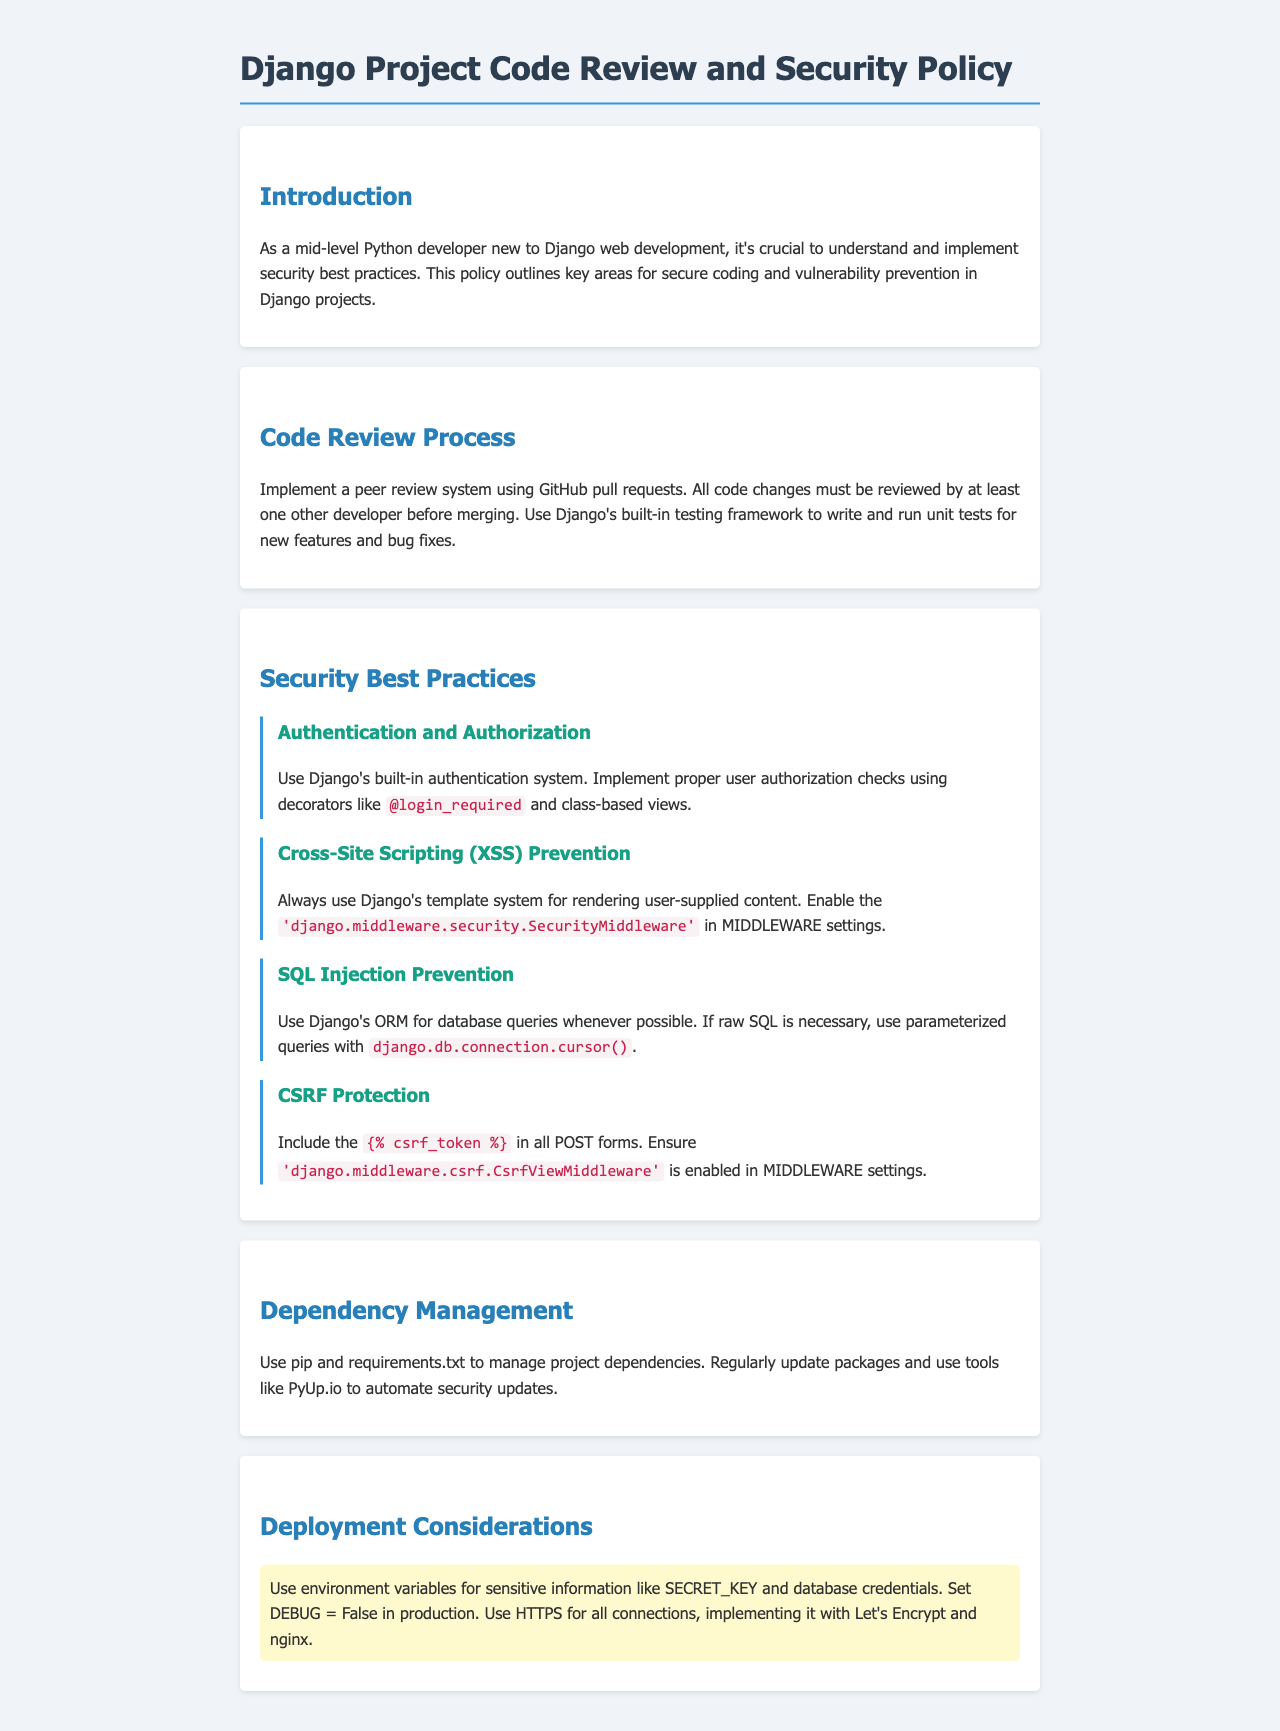What is the primary focus of the document? The primary focus of the document is to outline security best practices for Django web development.
Answer: security best practices What is the process for code review mentioned in the document? The document states that a peer review system using GitHub pull requests must be implemented.
Answer: peer review system Which middleware should be enabled for XSS prevention? The document mentions that the 'django.middleware.security.SecurityMiddleware' should be enabled in MIDDLEWARE settings.
Answer: 'django.middleware.security.SecurityMiddleware' What should be included in all POST forms for CSRF protection? The document indicates that '{% csrf_token %}' should be included in all POST forms.
Answer: {% csrf_token %} What should you set DEBUG to in production? The document specifies that DEBUG should be set to False in production.
Answer: False How should sensitive information be handled in deployment? According to the document, sensitive information should be handled using environment variables.
Answer: environment variables What tool can be used to automate security updates? The document suggests using tools like PyUp.io for automating security updates.
Answer: PyUp.io How many developers must review code changes before merging? The document states that all code changes must be reviewed by at least one other developer before merging.
Answer: one other developer 